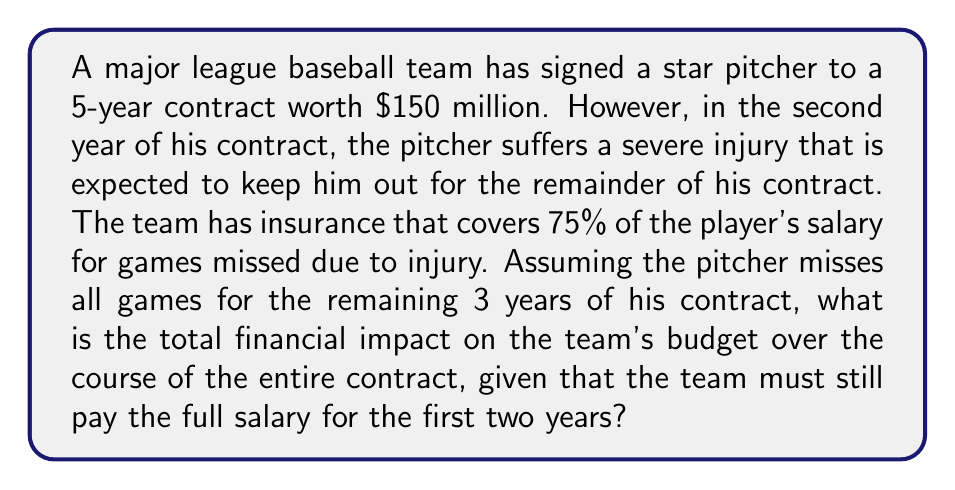Solve this math problem. Let's break this down step-by-step:

1) First, calculate the annual salary:
   $\frac{\$150,000,000}{5 \text{ years}} = \$30,000,000$ per year

2) The team pays full salary for the first two years:
   $2 \times \$30,000,000 = \$60,000,000$

3) For the remaining 3 years, the team must pay the salary, but will receive insurance compensation:
   - Salary owed: $3 \times \$30,000,000 = \$90,000,000$
   - Insurance covers 75%: $0.75 \times \$90,000,000 = \$67,500,000$
   - Team's responsibility: $\$90,000,000 - \$67,500,000 = \$22,500,000$

4) Total financial impact:
   $\$60,000,000 + \$22,500,000 = \$82,500,000$

5) To find the impact compared to the original contract value:
   $\$150,000,000 - \$82,500,000 = \$67,500,000$

Therefore, the team saves $67,500,000 compared to the original contract value, but this doesn't account for the lost performance value of the player.
Answer: The total financial impact on the team's budget over the course of the entire contract is $\$82,500,000$. 